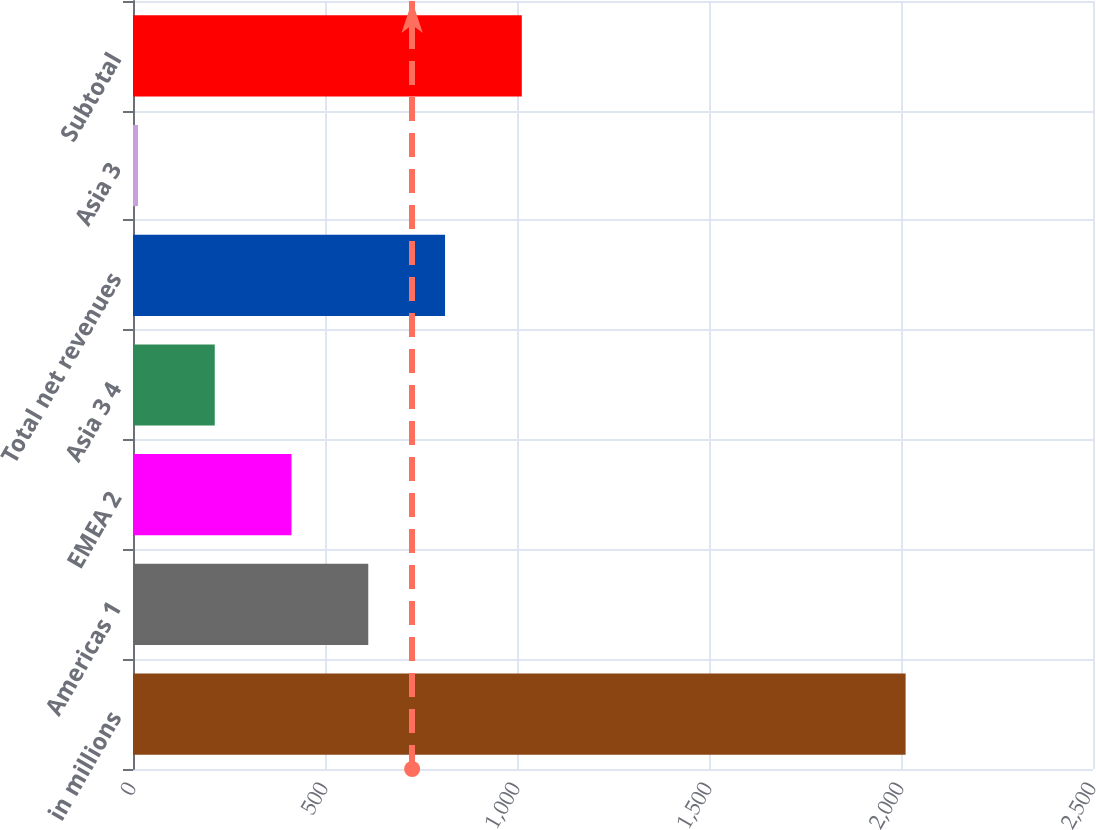<chart> <loc_0><loc_0><loc_500><loc_500><bar_chart><fcel>in millions<fcel>Americas 1<fcel>EMEA 2<fcel>Asia 3 4<fcel>Total net revenues<fcel>Asia 3<fcel>Subtotal<nl><fcel>2012<fcel>612.7<fcel>412.8<fcel>212.9<fcel>812.6<fcel>13<fcel>1012.5<nl></chart> 